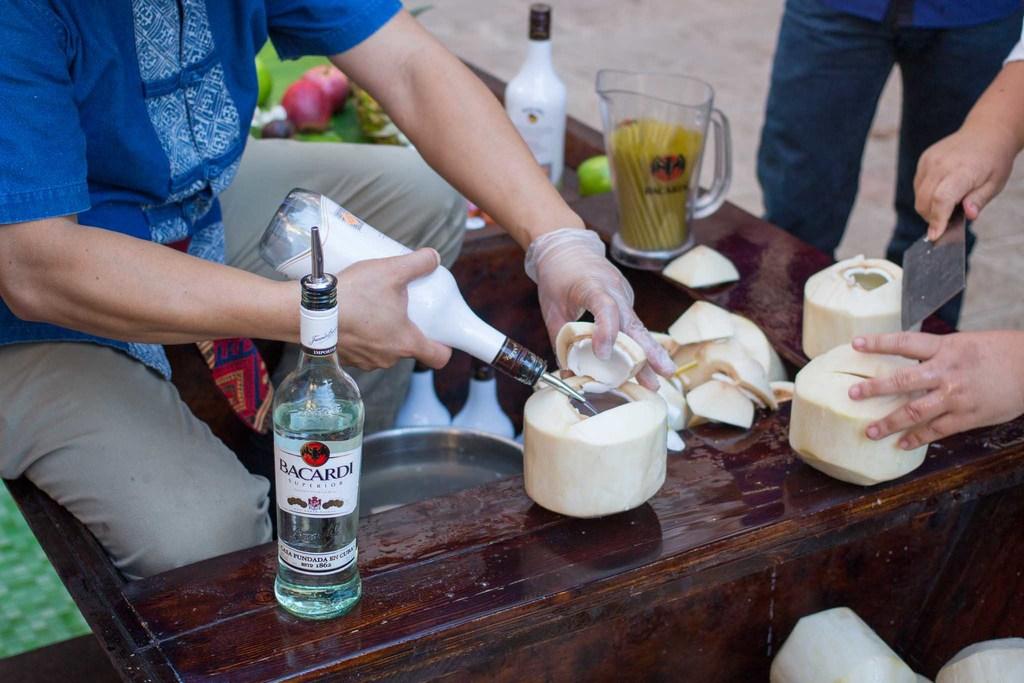What's the name of this alcoholic beverage?
Ensure brevity in your answer.  Bacardi. 